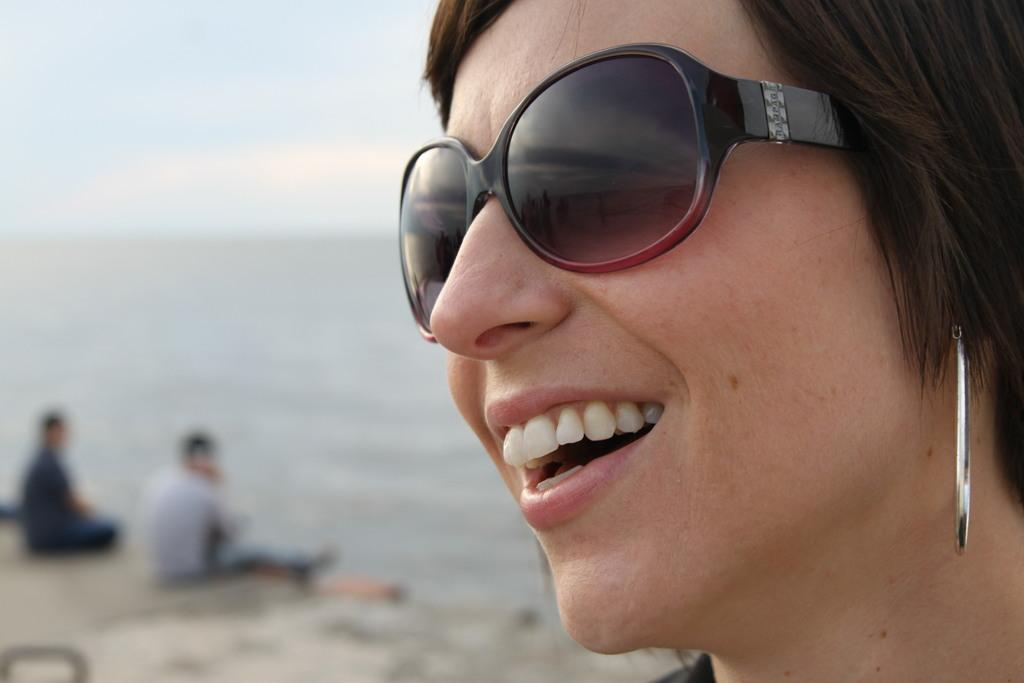Who is present in the image? There is a woman in the image. What is the woman wearing on her face? The woman is wearing black-colored goggles. What type of jewelry is the woman wearing? The woman is wearing silver-colored earrings. What can be seen in the background of the image? There is ground visible in the background of the image, and two persons are sitting on the ground. What is visible above the ground in the background? The sky is visible in the background of the image. What type of laborer is working on the chicken in the image? There is no laborer or chicken present in the image. What type of beast is visible in the background of the image? There are no beasts visible in the image; only a woman, ground, two persons sitting on the ground, and the sky are present. 